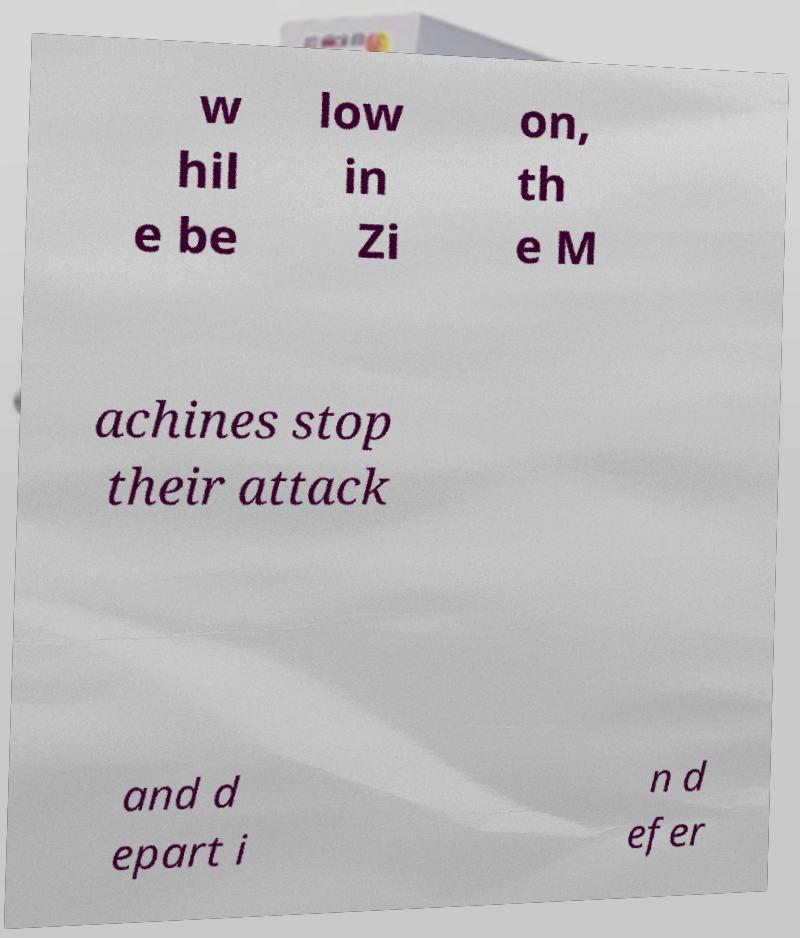For documentation purposes, I need the text within this image transcribed. Could you provide that? w hil e be low in Zi on, th e M achines stop their attack and d epart i n d efer 